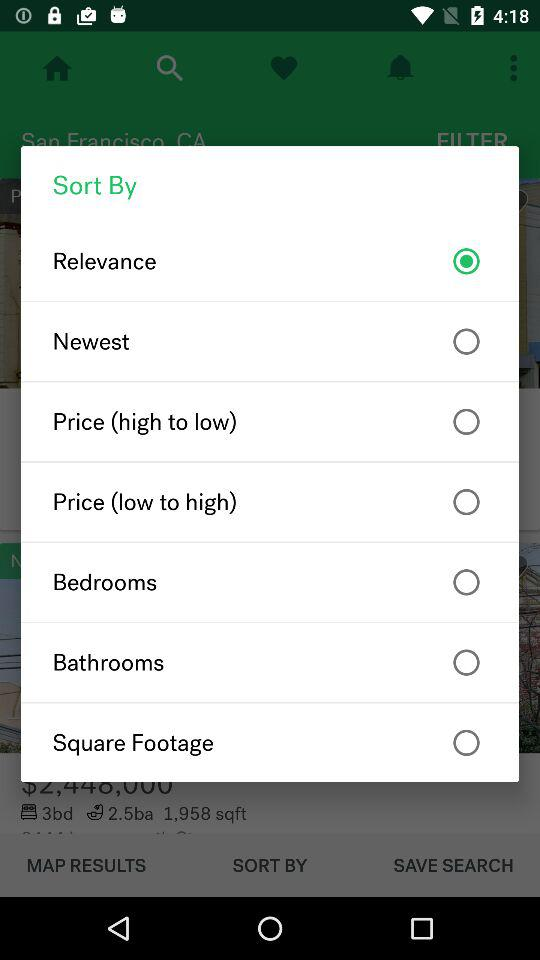Is "Bedrooms" selected or not? "Bedrooms" is not selected. 